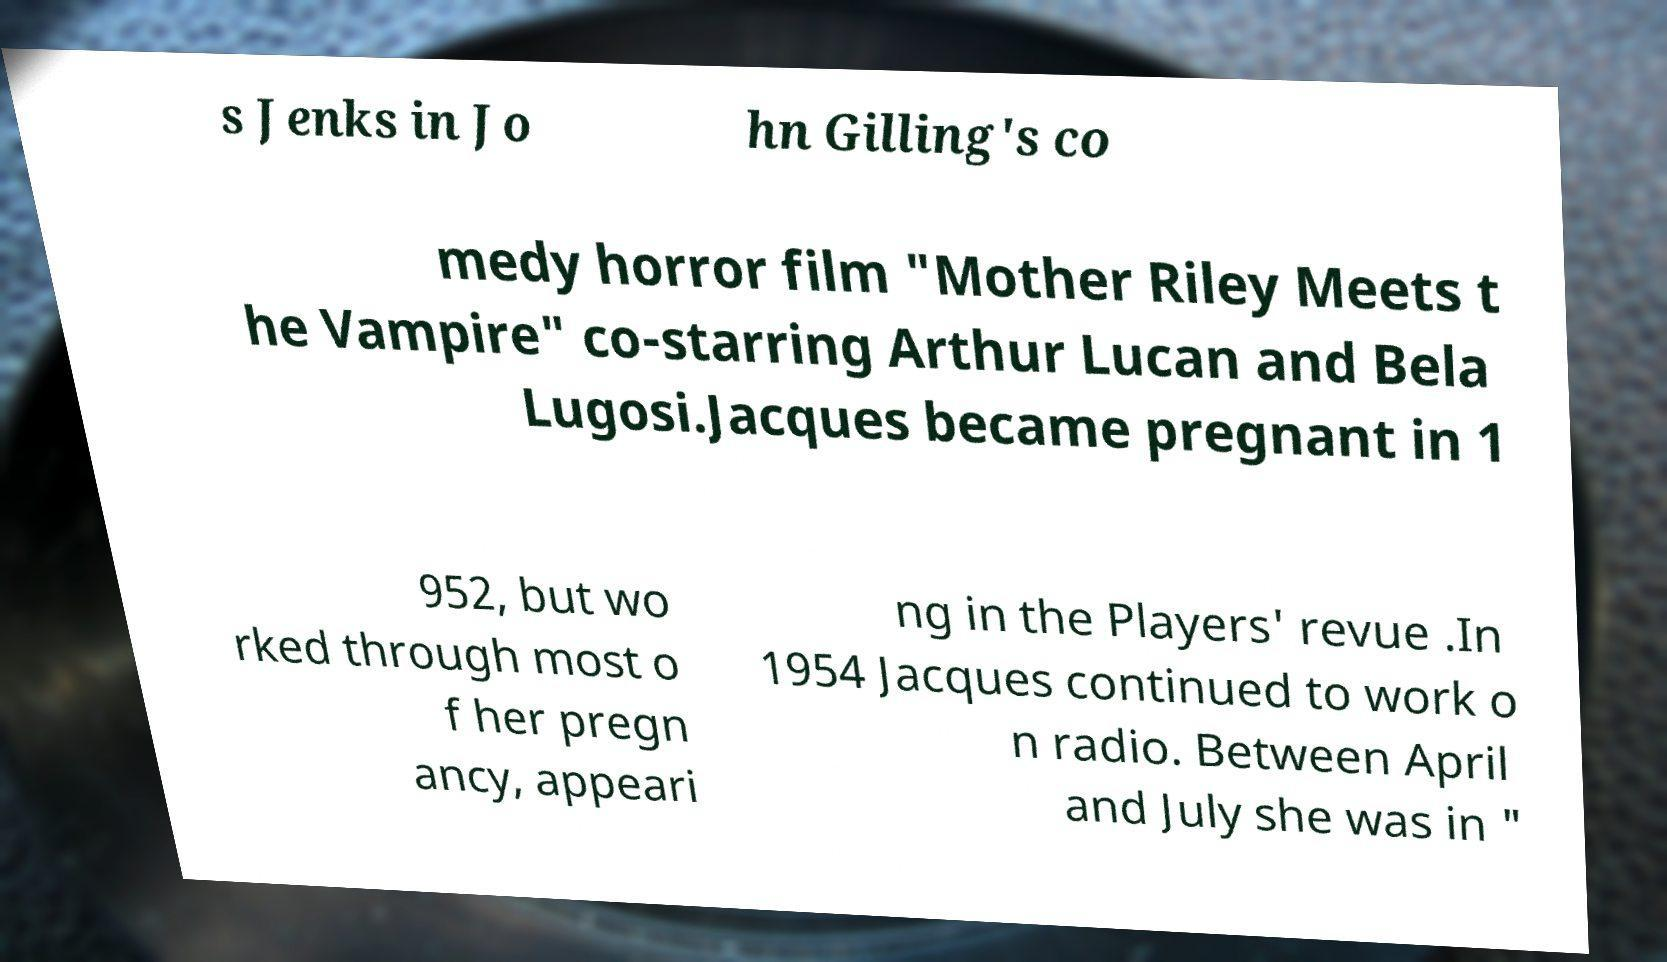Can you read and provide the text displayed in the image?This photo seems to have some interesting text. Can you extract and type it out for me? s Jenks in Jo hn Gilling's co medy horror film "Mother Riley Meets t he Vampire" co-starring Arthur Lucan and Bela Lugosi.Jacques became pregnant in 1 952, but wo rked through most o f her pregn ancy, appeari ng in the Players' revue .In 1954 Jacques continued to work o n radio. Between April and July she was in " 